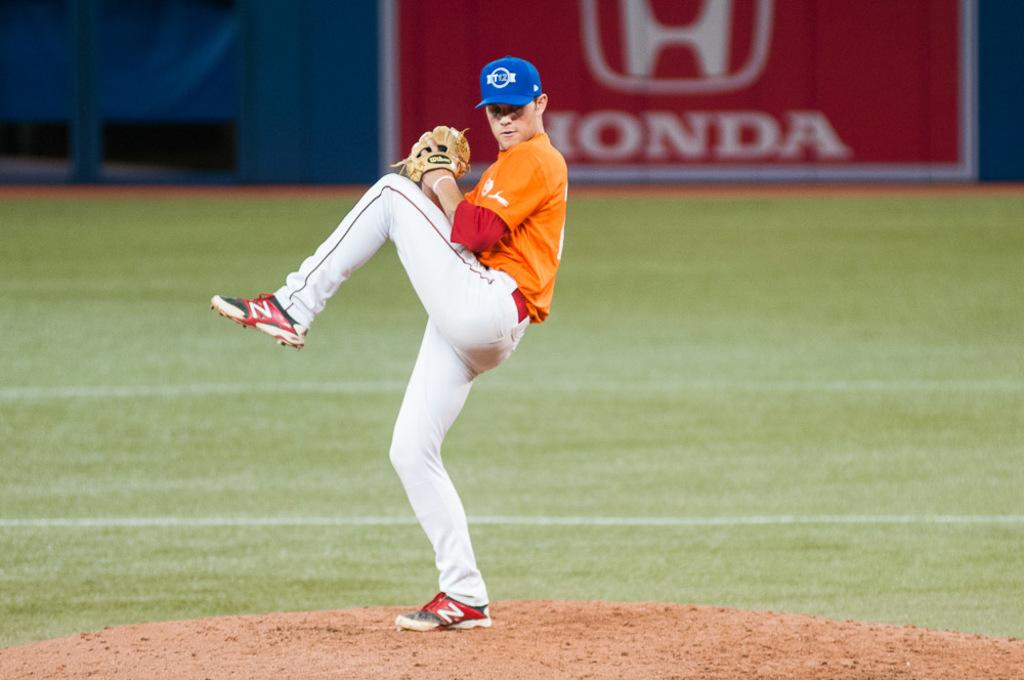<image>
Render a clear and concise summary of the photo. a pitcher playing baseball with a Honda ad behind them 